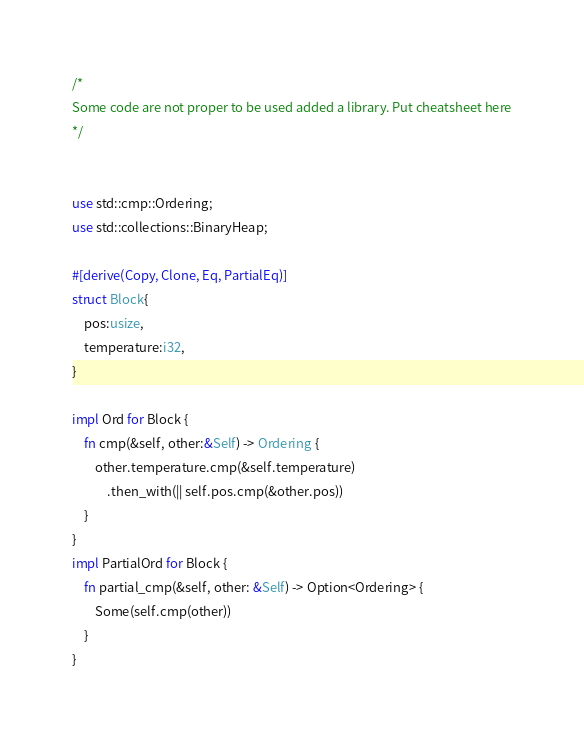<code> <loc_0><loc_0><loc_500><loc_500><_Rust_>/*
Some code are not proper to be used added a library. Put cheatsheet here
*/


use std::cmp::Ordering;
use std::collections::BinaryHeap;

#[derive(Copy, Clone, Eq, PartialEq)]
struct Block{
    pos:usize,
    temperature:i32,
}

impl Ord for Block {
    fn cmp(&self, other:&Self) -> Ordering {
        other.temperature.cmp(&self.temperature)
            .then_with(|| self.pos.cmp(&other.pos))
    }
}
impl PartialOrd for Block {
    fn partial_cmp(&self, other: &Self) -> Option<Ordering> {
        Some(self.cmp(other))
    }
}
</code> 